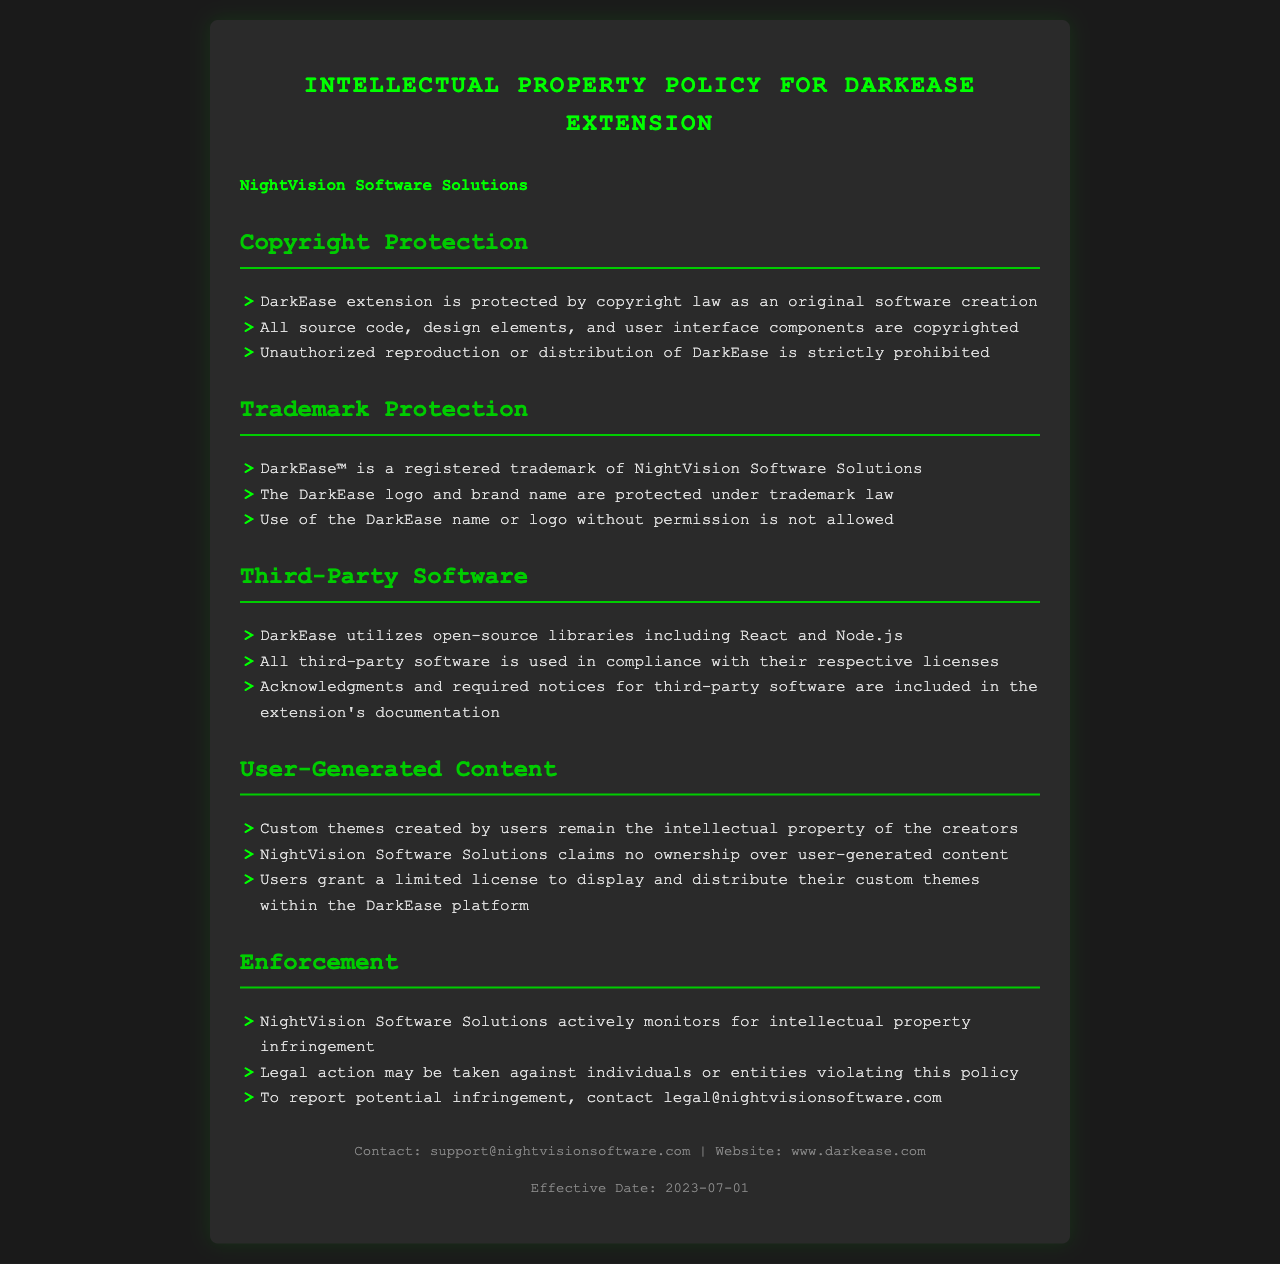What is the name of the dark mode extension? The name of the dark mode extension is mentioned in the document's title.
Answer: DarkEase Who is the trademark owner of DarkEase? The document specifies the owner of the trademark related to DarkEase.
Answer: NightVision Software Solutions What is the effective date of the policy? The effective date is provided at the end of the document.
Answer: 2023-07-01 What are the components that are copyrighted? The document lists the components that are protected by copyright law.
Answer: Source code, design elements, user interface components Is user-generated content owned by NightVision Software Solutions? The document states the ownership status of user-generated content.
Answer: No What action may be taken against intellectual property infringement? The document outlines the potential consequences for violations of the policy.
Answer: Legal action What open-source libraries does DarkEase utilize? The document mentions specific libraries that DarkEase includes.
Answer: React and Node.js What does a user grant to NightVision for their custom themes? The document explains what rights the user provides in relation to their custom themes.
Answer: A limited license to display and distribute What is the contact email for reporting potential infringement? The document provides a specific email for reporting infringement.
Answer: legal@nightvisionsoftware.com 